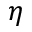Convert formula to latex. <formula><loc_0><loc_0><loc_500><loc_500>\eta</formula> 